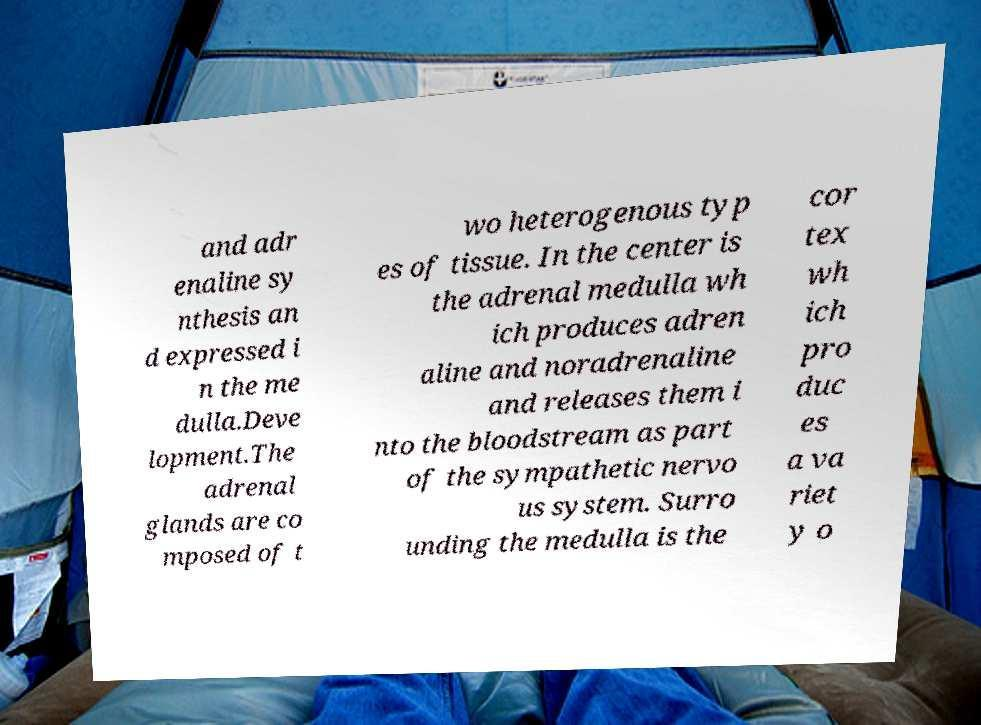Could you extract and type out the text from this image? and adr enaline sy nthesis an d expressed i n the me dulla.Deve lopment.The adrenal glands are co mposed of t wo heterogenous typ es of tissue. In the center is the adrenal medulla wh ich produces adren aline and noradrenaline and releases them i nto the bloodstream as part of the sympathetic nervo us system. Surro unding the medulla is the cor tex wh ich pro duc es a va riet y o 